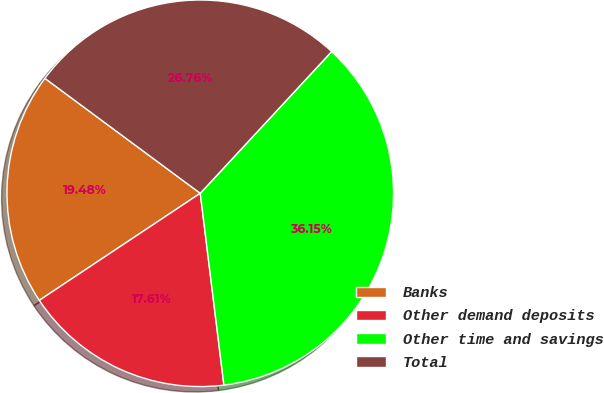Convert chart to OTSL. <chart><loc_0><loc_0><loc_500><loc_500><pie_chart><fcel>Banks<fcel>Other demand deposits<fcel>Other time and savings<fcel>Total<nl><fcel>19.48%<fcel>17.61%<fcel>36.15%<fcel>26.76%<nl></chart> 